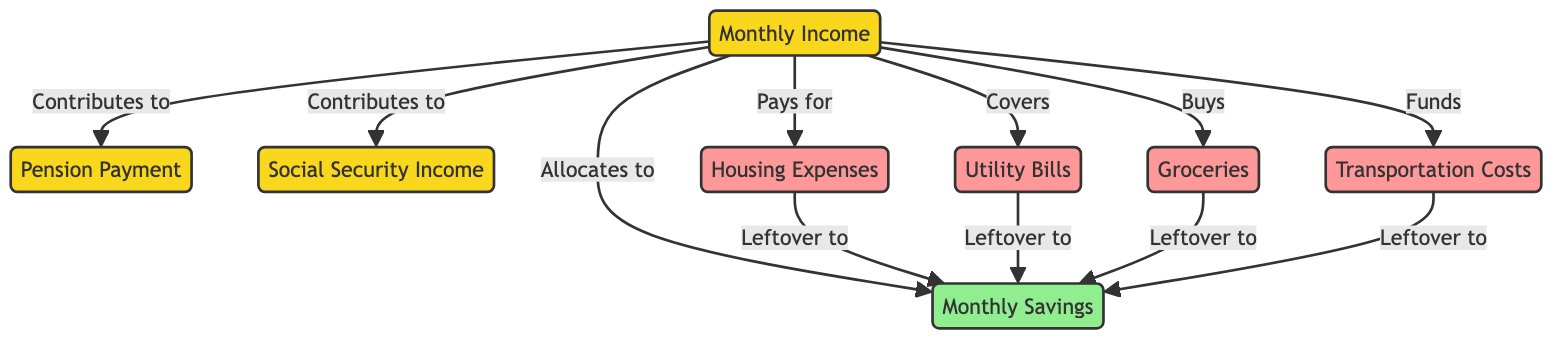What nodes are connected to Monthly Income? The diagram shows that Monthly Income is connected to Pension Payment, Social Security Income, Monthly Savings, Housing Expenses, Utility Bills, Groceries, and Transportation Costs. Each connection indicates how these categories are funded directly from the income source.
Answer: Pension Payment, Social Security Income, Monthly Savings, Housing Expenses, Utility Bills, Groceries, Transportation Costs Which expenses directly affect savings? In the diagram, the utilities, housing, groceries, and transportation nodes all have arrows leading into the savings node, indicating that leftover amounts after these expenses contribute directly to savings.
Answer: Housing, Utilities, Groceries, Transportation How many nodes are related to expenses? The diagram indicates there are four specific expense nodes: Housing Expenses, Utility Bills, Groceries, and Transportation Costs. Each is involved in the outflow from income.
Answer: Four What is the relationship between Housing Expenses and Monthly Savings? The diagram shows a directed edge from Housing Expenses to Monthly Savings, implying that there are leftover amounts from housing expenses that can be saved. This creates a positive relationship where savings may increase as housing expenses decrease.
Answer: Leftover to Savings How many edges are depicted in the diagram? By counting the arrows (or edges) shown in the diagram, each arrow represents a relationship or contribution between nodes. The total count yields a definitive number of connections.
Answer: Eleven What happens if monthly income increases? An increase in monthly income would enhance contributions to all connected nodes, thus potentially increasing the amounts allocated to savings, housing, utilities, groceries, and transportation; this incremental flow can mean better financial management overall.
Answer: Increased contributions to all connected nodes Which income sources directly contribute to savings? The diagram indicates Monthly Income directly allocates funds to Monthly Savings, and there are also leftover amounts from Housing, Utilities, Groceries, and Transportation that contribute to savings. Therefore, all of these nodes indirectly influence savings as well.
Answer: Monthly Income, Housing, Utilities, Groceries, Transportation What is the main outcome of the income flow? The main outcome of the income flow, as depicted in the diagram, is the allocation of funds into various expense categories and the potential to increase Monthly Savings from those allocations. The nodes reflect a holistic view of personal finances and the opportunities for saving.
Answer: Monthly Savings 